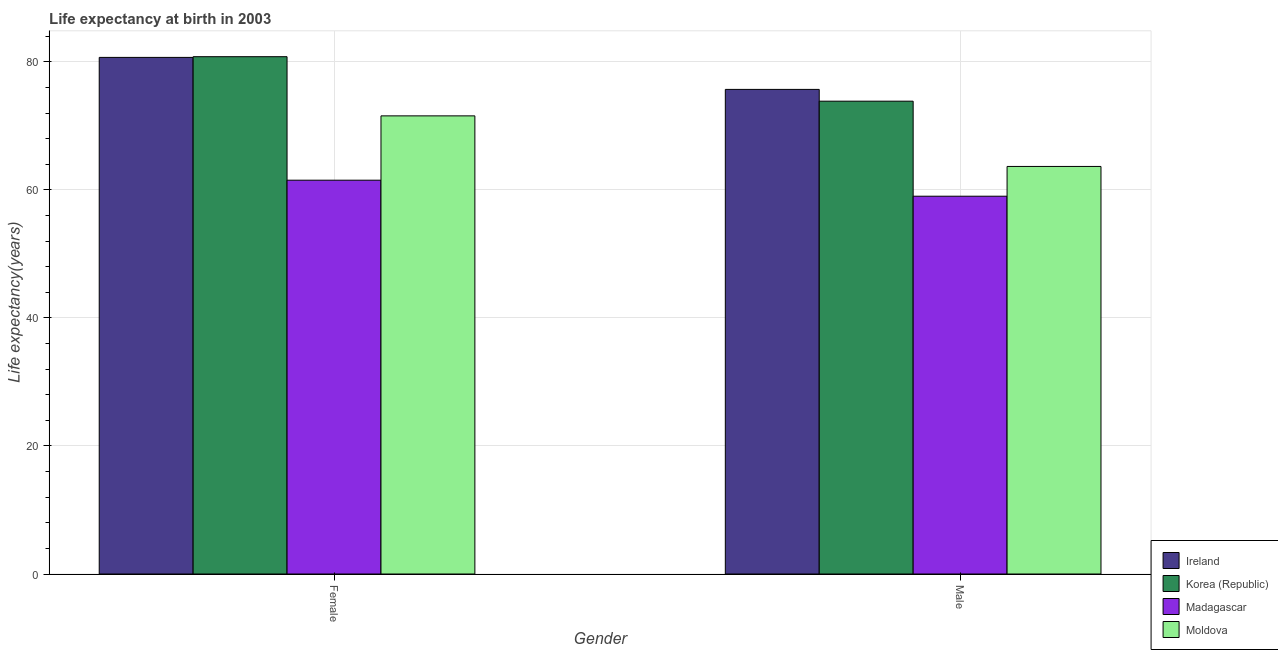How many groups of bars are there?
Make the answer very short. 2. Are the number of bars per tick equal to the number of legend labels?
Provide a short and direct response. Yes. Are the number of bars on each tick of the X-axis equal?
Ensure brevity in your answer.  Yes. How many bars are there on the 2nd tick from the right?
Your response must be concise. 4. What is the life expectancy(female) in Korea (Republic)?
Your answer should be very brief. 80.81. Across all countries, what is the maximum life expectancy(male)?
Keep it short and to the point. 75.7. Across all countries, what is the minimum life expectancy(female)?
Make the answer very short. 61.52. In which country was the life expectancy(male) minimum?
Keep it short and to the point. Madagascar. What is the total life expectancy(female) in the graph?
Offer a terse response. 294.59. What is the difference between the life expectancy(male) in Madagascar and that in Ireland?
Your answer should be very brief. -16.68. What is the difference between the life expectancy(male) in Moldova and the life expectancy(female) in Korea (Republic)?
Your answer should be very brief. -17.14. What is the average life expectancy(female) per country?
Provide a short and direct response. 73.65. What is the difference between the life expectancy(male) and life expectancy(female) in Korea (Republic)?
Provide a short and direct response. -6.95. In how many countries, is the life expectancy(female) greater than 8 years?
Offer a terse response. 4. What is the ratio of the life expectancy(female) in Madagascar to that in Ireland?
Give a very brief answer. 0.76. In how many countries, is the life expectancy(female) greater than the average life expectancy(female) taken over all countries?
Your answer should be compact. 2. What does the 1st bar from the left in Male represents?
Provide a short and direct response. Ireland. What does the 2nd bar from the right in Male represents?
Keep it short and to the point. Madagascar. Are all the bars in the graph horizontal?
Ensure brevity in your answer.  No. How many countries are there in the graph?
Your answer should be very brief. 4. Are the values on the major ticks of Y-axis written in scientific E-notation?
Your answer should be very brief. No. Does the graph contain any zero values?
Keep it short and to the point. No. Does the graph contain grids?
Offer a very short reply. Yes. Where does the legend appear in the graph?
Offer a terse response. Bottom right. How many legend labels are there?
Provide a succinct answer. 4. How are the legend labels stacked?
Your response must be concise. Vertical. What is the title of the graph?
Provide a succinct answer. Life expectancy at birth in 2003. What is the label or title of the X-axis?
Your response must be concise. Gender. What is the label or title of the Y-axis?
Offer a terse response. Life expectancy(years). What is the Life expectancy(years) in Ireland in Female?
Keep it short and to the point. 80.7. What is the Life expectancy(years) in Korea (Republic) in Female?
Offer a very short reply. 80.81. What is the Life expectancy(years) in Madagascar in Female?
Ensure brevity in your answer.  61.52. What is the Life expectancy(years) in Moldova in Female?
Offer a very short reply. 71.57. What is the Life expectancy(years) in Ireland in Male?
Your response must be concise. 75.7. What is the Life expectancy(years) of Korea (Republic) in Male?
Your answer should be very brief. 73.86. What is the Life expectancy(years) of Madagascar in Male?
Make the answer very short. 59.02. What is the Life expectancy(years) of Moldova in Male?
Provide a short and direct response. 63.67. Across all Gender, what is the maximum Life expectancy(years) in Ireland?
Your answer should be very brief. 80.7. Across all Gender, what is the maximum Life expectancy(years) in Korea (Republic)?
Ensure brevity in your answer.  80.81. Across all Gender, what is the maximum Life expectancy(years) in Madagascar?
Provide a short and direct response. 61.52. Across all Gender, what is the maximum Life expectancy(years) of Moldova?
Provide a succinct answer. 71.57. Across all Gender, what is the minimum Life expectancy(years) of Ireland?
Your answer should be very brief. 75.7. Across all Gender, what is the minimum Life expectancy(years) of Korea (Republic)?
Your response must be concise. 73.86. Across all Gender, what is the minimum Life expectancy(years) of Madagascar?
Offer a very short reply. 59.02. Across all Gender, what is the minimum Life expectancy(years) in Moldova?
Your response must be concise. 63.67. What is the total Life expectancy(years) of Ireland in the graph?
Ensure brevity in your answer.  156.4. What is the total Life expectancy(years) in Korea (Republic) in the graph?
Offer a very short reply. 154.67. What is the total Life expectancy(years) of Madagascar in the graph?
Offer a very short reply. 120.53. What is the total Life expectancy(years) of Moldova in the graph?
Your answer should be very brief. 135.23. What is the difference between the Life expectancy(years) in Ireland in Female and that in Male?
Provide a short and direct response. 5. What is the difference between the Life expectancy(years) in Korea (Republic) in Female and that in Male?
Keep it short and to the point. 6.95. What is the difference between the Life expectancy(years) of Madagascar in Female and that in Male?
Your response must be concise. 2.5. What is the difference between the Life expectancy(years) in Moldova in Female and that in Male?
Make the answer very short. 7.9. What is the difference between the Life expectancy(years) of Ireland in Female and the Life expectancy(years) of Korea (Republic) in Male?
Keep it short and to the point. 6.84. What is the difference between the Life expectancy(years) of Ireland in Female and the Life expectancy(years) of Madagascar in Male?
Offer a terse response. 21.68. What is the difference between the Life expectancy(years) of Ireland in Female and the Life expectancy(years) of Moldova in Male?
Your answer should be very brief. 17.03. What is the difference between the Life expectancy(years) in Korea (Republic) in Female and the Life expectancy(years) in Madagascar in Male?
Provide a short and direct response. 21.79. What is the difference between the Life expectancy(years) in Korea (Republic) in Female and the Life expectancy(years) in Moldova in Male?
Your answer should be very brief. 17.14. What is the difference between the Life expectancy(years) in Madagascar in Female and the Life expectancy(years) in Moldova in Male?
Ensure brevity in your answer.  -2.15. What is the average Life expectancy(years) of Ireland per Gender?
Offer a terse response. 78.2. What is the average Life expectancy(years) in Korea (Republic) per Gender?
Your answer should be very brief. 77.33. What is the average Life expectancy(years) of Madagascar per Gender?
Your response must be concise. 60.27. What is the average Life expectancy(years) in Moldova per Gender?
Make the answer very short. 67.62. What is the difference between the Life expectancy(years) in Ireland and Life expectancy(years) in Korea (Republic) in Female?
Your answer should be compact. -0.11. What is the difference between the Life expectancy(years) of Ireland and Life expectancy(years) of Madagascar in Female?
Your answer should be compact. 19.18. What is the difference between the Life expectancy(years) of Ireland and Life expectancy(years) of Moldova in Female?
Provide a succinct answer. 9.13. What is the difference between the Life expectancy(years) of Korea (Republic) and Life expectancy(years) of Madagascar in Female?
Your answer should be very brief. 19.29. What is the difference between the Life expectancy(years) of Korea (Republic) and Life expectancy(years) of Moldova in Female?
Offer a terse response. 9.24. What is the difference between the Life expectancy(years) of Madagascar and Life expectancy(years) of Moldova in Female?
Your answer should be compact. -10.05. What is the difference between the Life expectancy(years) of Ireland and Life expectancy(years) of Korea (Republic) in Male?
Provide a succinct answer. 1.84. What is the difference between the Life expectancy(years) in Ireland and Life expectancy(years) in Madagascar in Male?
Give a very brief answer. 16.68. What is the difference between the Life expectancy(years) in Ireland and Life expectancy(years) in Moldova in Male?
Make the answer very short. 12.03. What is the difference between the Life expectancy(years) in Korea (Republic) and Life expectancy(years) in Madagascar in Male?
Ensure brevity in your answer.  14.84. What is the difference between the Life expectancy(years) of Korea (Republic) and Life expectancy(years) of Moldova in Male?
Ensure brevity in your answer.  10.19. What is the difference between the Life expectancy(years) in Madagascar and Life expectancy(years) in Moldova in Male?
Your response must be concise. -4.65. What is the ratio of the Life expectancy(years) in Ireland in Female to that in Male?
Your response must be concise. 1.07. What is the ratio of the Life expectancy(years) of Korea (Republic) in Female to that in Male?
Provide a succinct answer. 1.09. What is the ratio of the Life expectancy(years) of Madagascar in Female to that in Male?
Provide a short and direct response. 1.04. What is the ratio of the Life expectancy(years) in Moldova in Female to that in Male?
Give a very brief answer. 1.12. What is the difference between the highest and the second highest Life expectancy(years) in Ireland?
Your answer should be compact. 5. What is the difference between the highest and the second highest Life expectancy(years) in Korea (Republic)?
Ensure brevity in your answer.  6.95. What is the difference between the highest and the second highest Life expectancy(years) of Moldova?
Provide a short and direct response. 7.9. What is the difference between the highest and the lowest Life expectancy(years) in Korea (Republic)?
Give a very brief answer. 6.95. What is the difference between the highest and the lowest Life expectancy(years) in Madagascar?
Offer a very short reply. 2.5. What is the difference between the highest and the lowest Life expectancy(years) in Moldova?
Your answer should be compact. 7.9. 